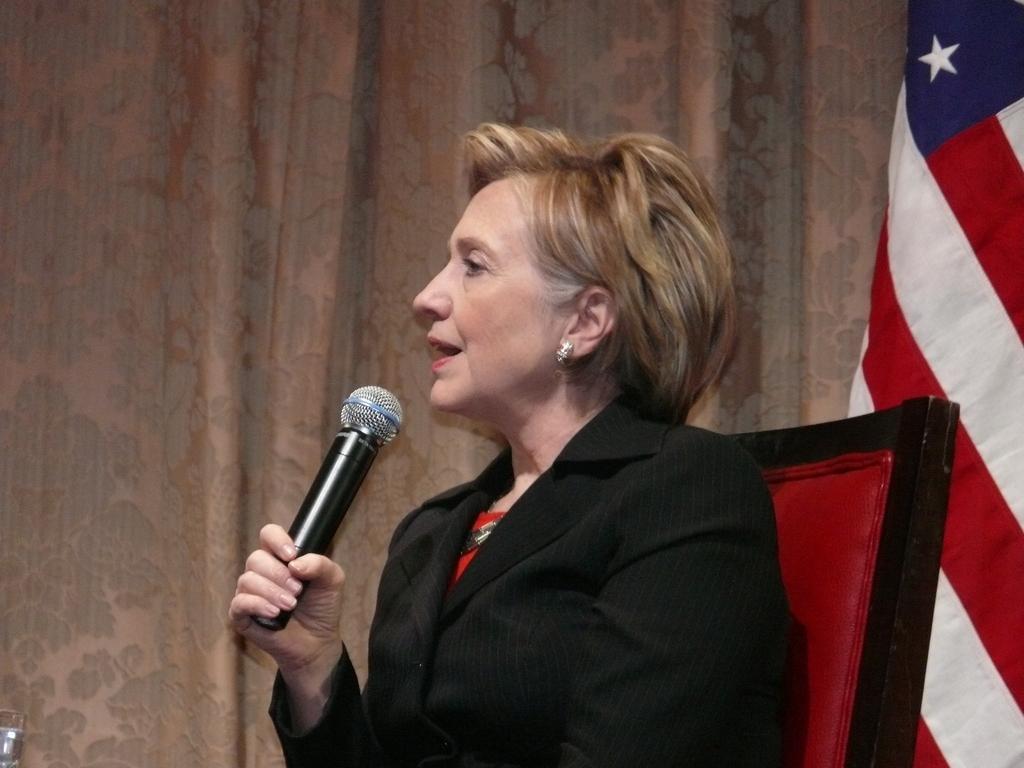In one or two sentences, can you explain what this image depicts? a person is sitting on a chair, wearing black suit, holding a microphone in her hand. at the right there is a flag. behind her there are curtains. 